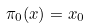Convert formula to latex. <formula><loc_0><loc_0><loc_500><loc_500>\pi _ { 0 } ( x ) = x _ { 0 }</formula> 